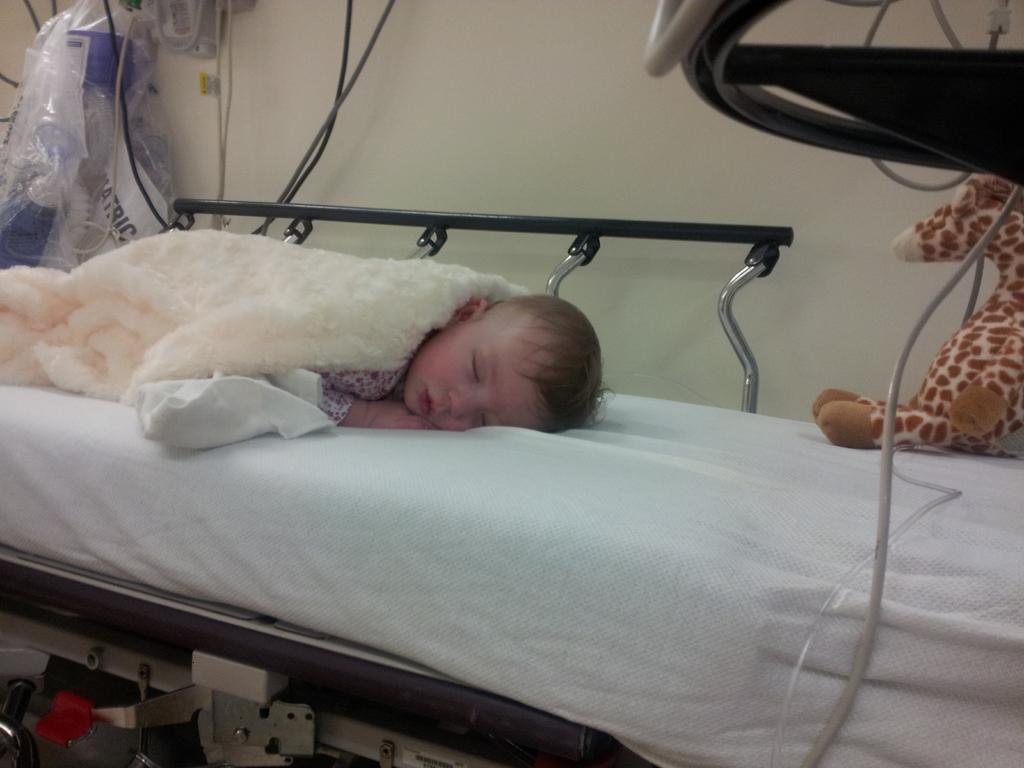Describe this image in one or two sentences. In this image I can see a baby is sleeping on bed, toy, blanket and wire. In the background I can see a wall, covers and metal rods. This image is taken may be in a room. 